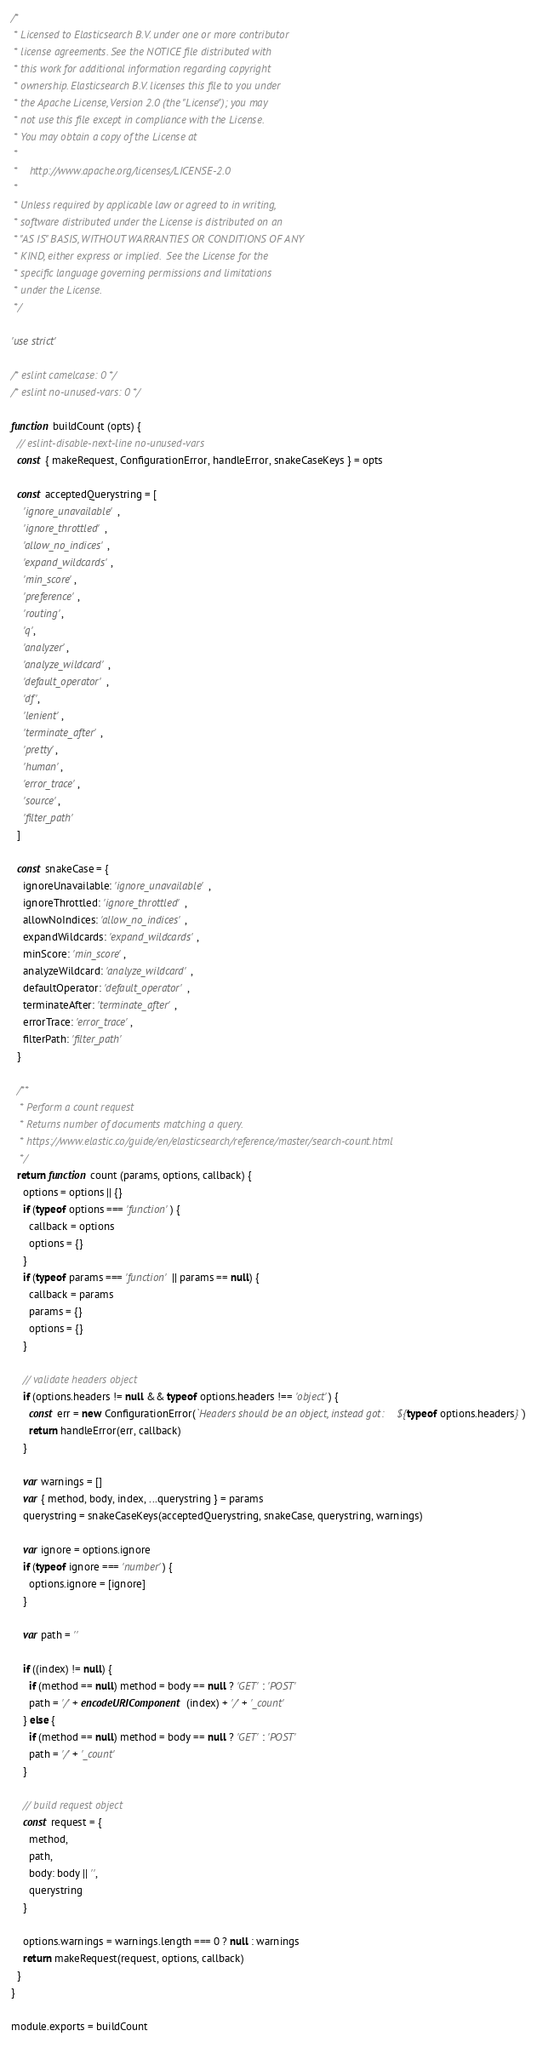Convert code to text. <code><loc_0><loc_0><loc_500><loc_500><_JavaScript_>/*
 * Licensed to Elasticsearch B.V. under one or more contributor
 * license agreements. See the NOTICE file distributed with
 * this work for additional information regarding copyright
 * ownership. Elasticsearch B.V. licenses this file to you under
 * the Apache License, Version 2.0 (the "License"); you may
 * not use this file except in compliance with the License.
 * You may obtain a copy of the License at
 *
 *    http://www.apache.org/licenses/LICENSE-2.0
 *
 * Unless required by applicable law or agreed to in writing,
 * software distributed under the License is distributed on an
 * "AS IS" BASIS, WITHOUT WARRANTIES OR CONDITIONS OF ANY
 * KIND, either express or implied.  See the License for the
 * specific language governing permissions and limitations
 * under the License.
 */

'use strict'

/* eslint camelcase: 0 */
/* eslint no-unused-vars: 0 */

function buildCount (opts) {
  // eslint-disable-next-line no-unused-vars
  const { makeRequest, ConfigurationError, handleError, snakeCaseKeys } = opts

  const acceptedQuerystring = [
    'ignore_unavailable',
    'ignore_throttled',
    'allow_no_indices',
    'expand_wildcards',
    'min_score',
    'preference',
    'routing',
    'q',
    'analyzer',
    'analyze_wildcard',
    'default_operator',
    'df',
    'lenient',
    'terminate_after',
    'pretty',
    'human',
    'error_trace',
    'source',
    'filter_path'
  ]

  const snakeCase = {
    ignoreUnavailable: 'ignore_unavailable',
    ignoreThrottled: 'ignore_throttled',
    allowNoIndices: 'allow_no_indices',
    expandWildcards: 'expand_wildcards',
    minScore: 'min_score',
    analyzeWildcard: 'analyze_wildcard',
    defaultOperator: 'default_operator',
    terminateAfter: 'terminate_after',
    errorTrace: 'error_trace',
    filterPath: 'filter_path'
  }

  /**
   * Perform a count request
   * Returns number of documents matching a query.
   * https://www.elastic.co/guide/en/elasticsearch/reference/master/search-count.html
   */
  return function count (params, options, callback) {
    options = options || {}
    if (typeof options === 'function') {
      callback = options
      options = {}
    }
    if (typeof params === 'function' || params == null) {
      callback = params
      params = {}
      options = {}
    }

    // validate headers object
    if (options.headers != null && typeof options.headers !== 'object') {
      const err = new ConfigurationError(`Headers should be an object, instead got: ${typeof options.headers}`)
      return handleError(err, callback)
    }

    var warnings = []
    var { method, body, index, ...querystring } = params
    querystring = snakeCaseKeys(acceptedQuerystring, snakeCase, querystring, warnings)

    var ignore = options.ignore
    if (typeof ignore === 'number') {
      options.ignore = [ignore]
    }

    var path = ''

    if ((index) != null) {
      if (method == null) method = body == null ? 'GET' : 'POST'
      path = '/' + encodeURIComponent(index) + '/' + '_count'
    } else {
      if (method == null) method = body == null ? 'GET' : 'POST'
      path = '/' + '_count'
    }

    // build request object
    const request = {
      method,
      path,
      body: body || '',
      querystring
    }

    options.warnings = warnings.length === 0 ? null : warnings
    return makeRequest(request, options, callback)
  }
}

module.exports = buildCount
</code> 